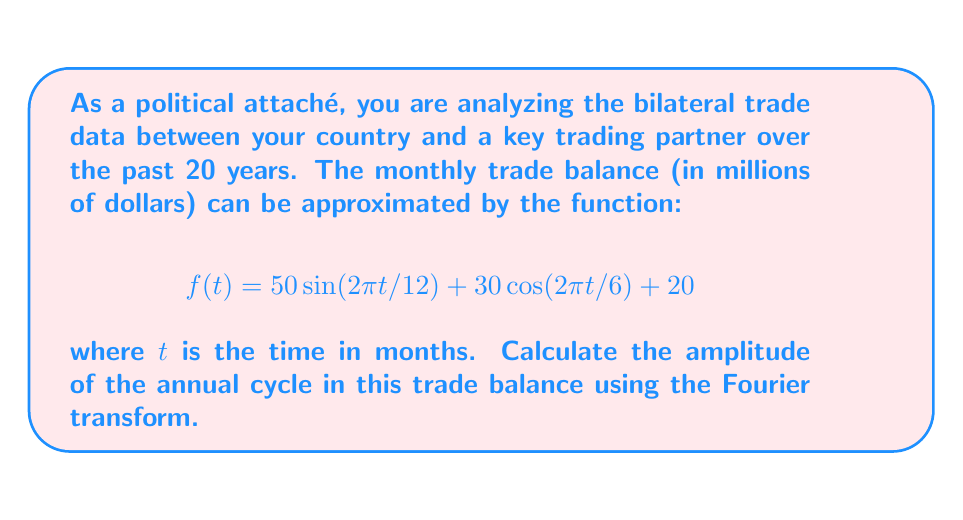Show me your answer to this math problem. To solve this problem, we'll follow these steps:

1) First, let's identify the components of the given function:
   $$f(t) = 50 \sin(2\pi t/12) + 30 \cos(2\pi t/6) + 20$$

   The first term represents an annual cycle (period of 12 months), the second term a semi-annual cycle (period of 6 months), and the last term is a constant offset.

2) The Fourier transform of a sinusoidal function is a pair of delta functions in the frequency domain. For a cosine function:

   $$\mathcal{F}\{A \cos(2\pi f_0 t)\} = \frac{A}{2}[\delta(f-f_0) + \delta(f+f_0)]$$

   For a sine function:

   $$\mathcal{F}\{A \sin(2\pi f_0 t)\} = \frac{A}{2i}[\delta(f-f_0) - \delta(f+f_0)]$$

3) In our case, we're interested in the annual cycle, which corresponds to the sine term:

   $$50 \sin(2\pi t/12)$$

   Here, $f_0 = 1/12$ (cycles per month).

4) Applying the Fourier transform to this term:

   $$\mathcal{F}\{50 \sin(2\pi t/12)\} = \frac{50}{2i}[\delta(f-1/12) - \delta(f+1/12)]$$

5) The amplitude in the frequency domain is the absolute value of the coefficient:

   $$\text{Amplitude} = \left|\frac{50}{2i}\right| = 25$$

Thus, the amplitude of the annual cycle in the frequency domain is 25 million dollars.
Answer: The amplitude of the annual cycle in the bilateral trade balance, as determined by the Fourier transform, is $25 million. 